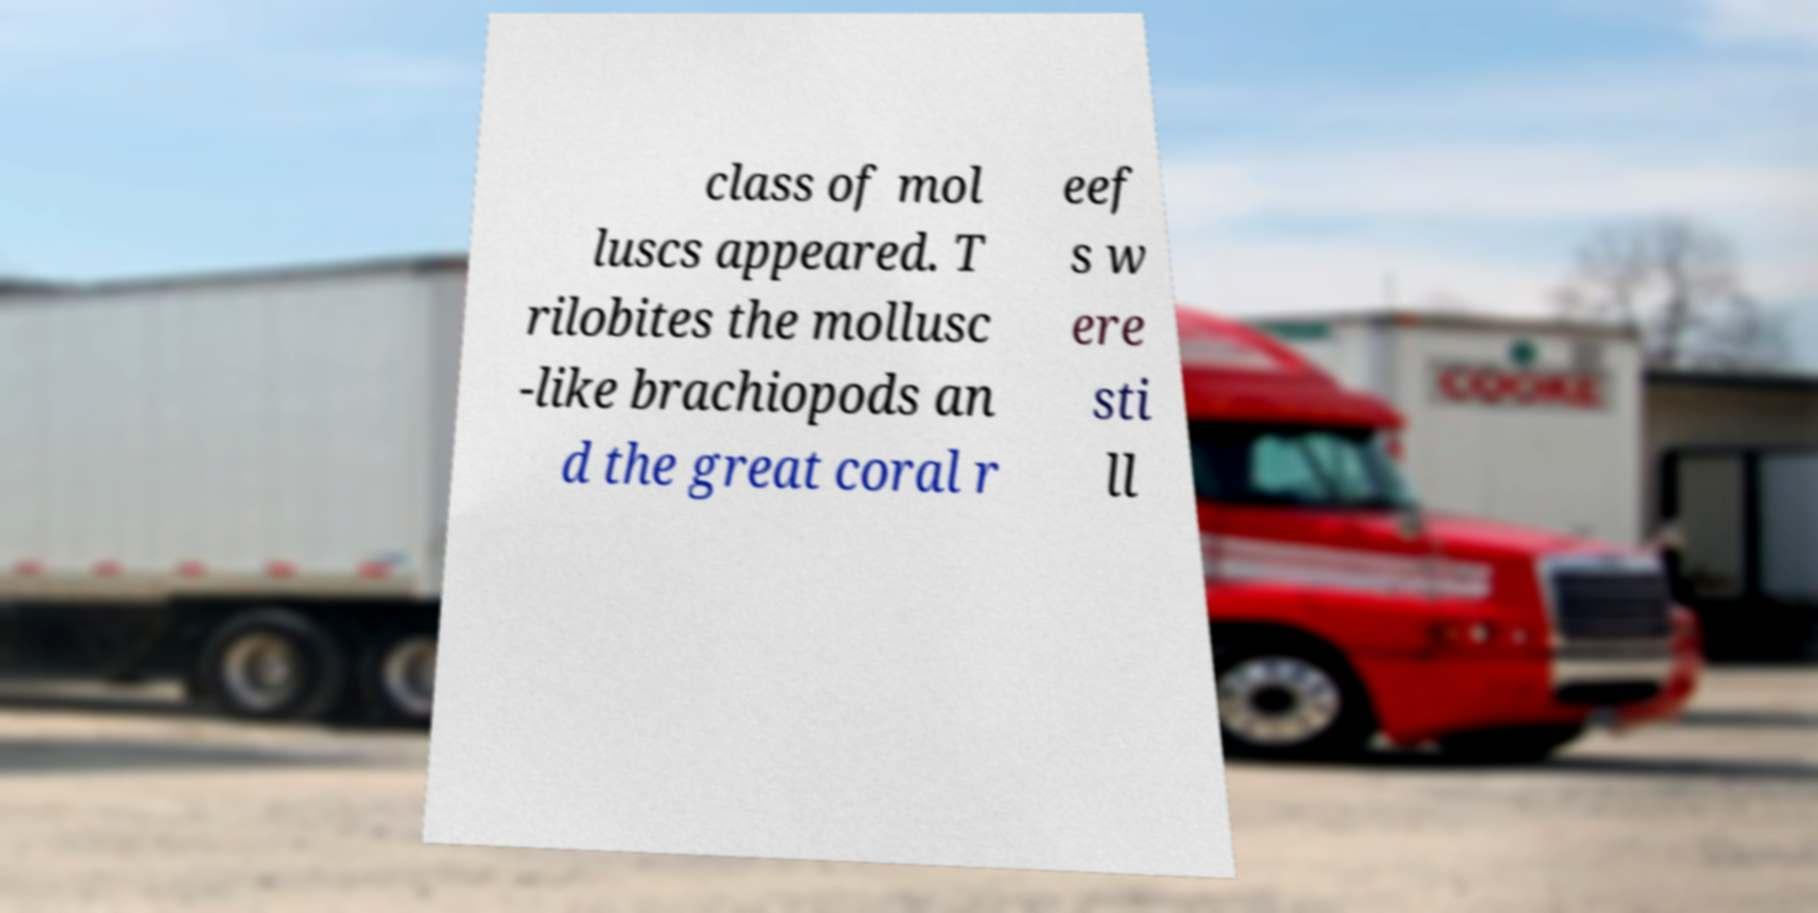What messages or text are displayed in this image? I need them in a readable, typed format. class of mol luscs appeared. T rilobites the mollusc -like brachiopods an d the great coral r eef s w ere sti ll 